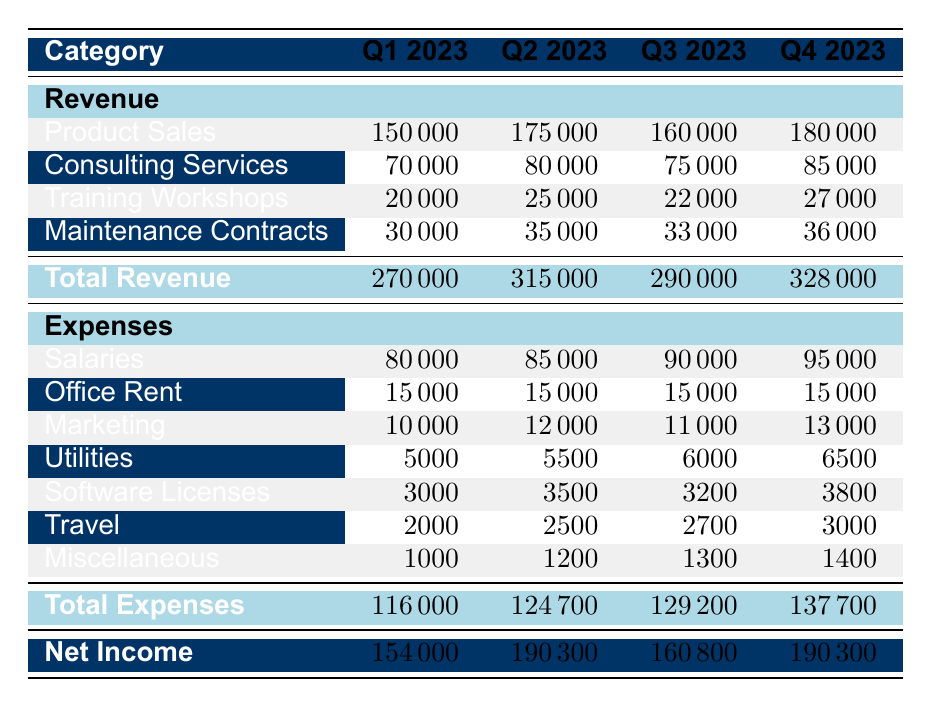What was the total revenue in Q3 2023? To find the total revenue for Q3 2023, we look at the total revenue row under Q3. The total revenue is mentioned as 290000.
Answer: 290000 What is the difference in total expenses between Q1 and Q2 2023? The total expenses for Q1 2023 is 116000 and for Q2 2023 is 124700. The difference is calculated as 124700 - 116000 = 7000.
Answer: 7000 Did the revenue from Consulting Services increase in Q4 compared to Q3? The revenue from Consulting Services in Q3 is 75000 and in Q4 is 85000. Since 85000 is greater than 75000, it confirms an increase.
Answer: Yes What was the average expenses for all quarters combined? To calculate the average expenses, we first sum the total expenses of each quarter: 116000 + 124700 + 129200 + 137700 = 507600. Then we divide by the number of quarters (4): 507600 / 4 = 126900.
Answer: 126900 What is the total revenue from Product Sales for the year 2023? To find the total revenue from Product Sales, sum the values from each quarter: 150000 + 175000 + 160000 + 180000 = 665000.
Answer: 665000 What was the highest single expense category in Q4 2023? In Q4 2023, the expenses listed are Salaries (95000), Office Rent (15000), Marketing (13000), Utilities (6500), Software Licenses (3800), Travel (3000), and Miscellaneous (1400). The highest is Salaries at 95000.
Answer: Salaries Is the total net income higher in Q2 2023 than in Q4 2023? The net income for Q2 2023 is 190300 whereas, for Q4 2023, it is also 190300. Since both values are equal, the net income is not higher.
Answer: No In which quarter did the company spend the least on Marketing? Reviewing the Marketing expenses by quarter shows: Q1 (10000), Q2 (12000), Q3 (11000), and Q4 (13000). The least is in Q1 at 10000.
Answer: Q1 